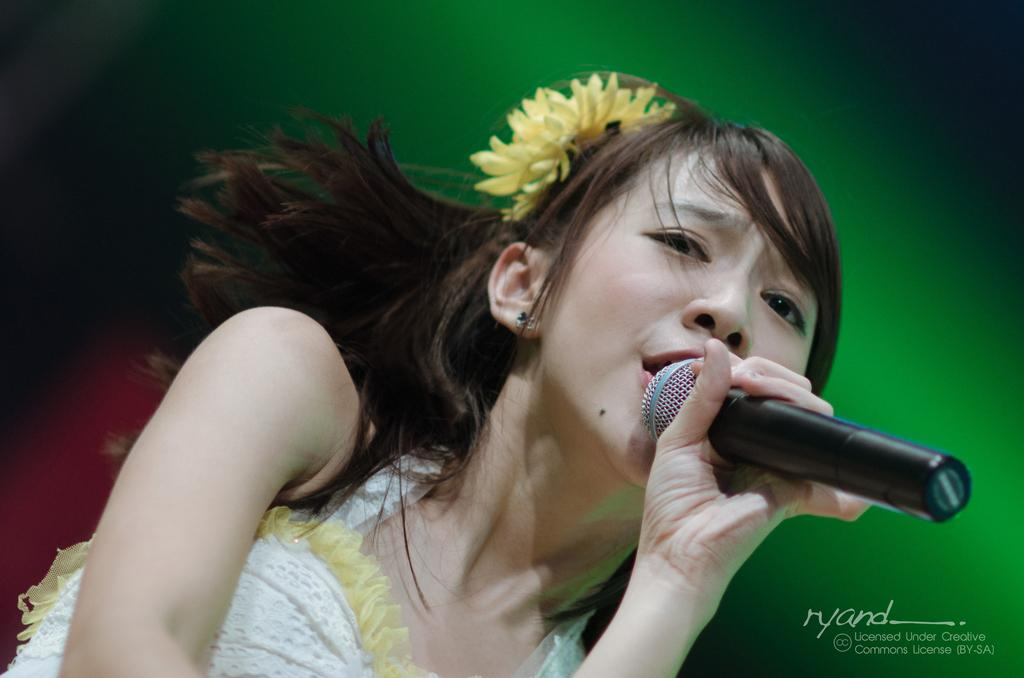Who is the main subject in the image? There is a woman in the image. What is the woman holding in the image? The woman is holding a microphone. What is the woman doing in the image? The woman is singing a song. What is the woman wearing in the image? The woman is wearing a white dress. What can be seen on the woman's head in the image? There is a yellow flower on her head. What is the color of the background in the image? The background of the image is green. How many rabbits can be seen hopping around in the image? There are no rabbits present in the image. What type of shoe is the woman wearing in the image? The woman is not wearing any shoes in the image; she is wearing a white dress. 